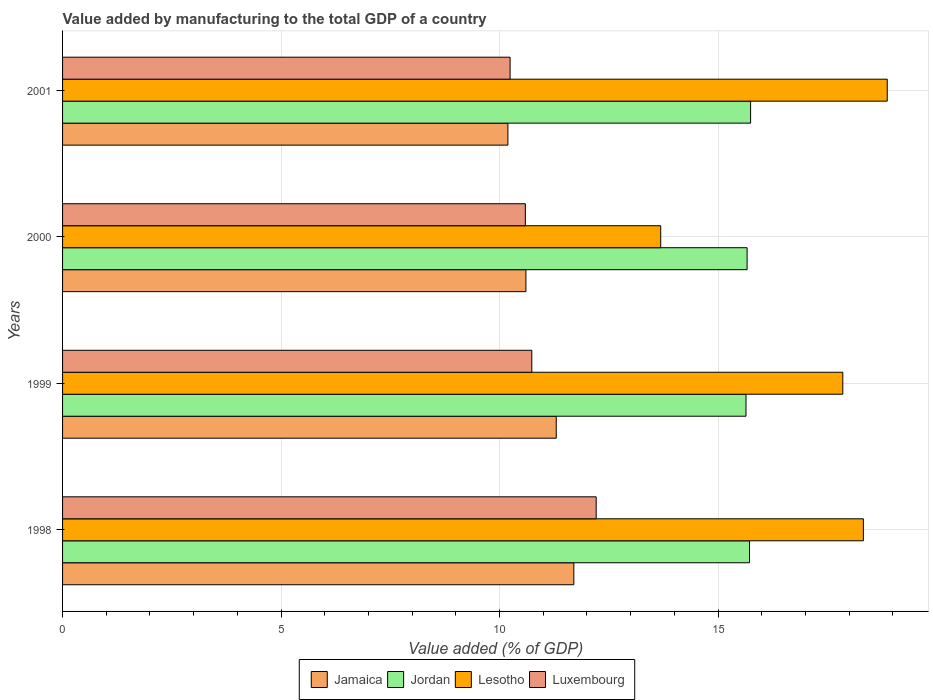How many bars are there on the 3rd tick from the bottom?
Ensure brevity in your answer.  4. In how many cases, is the number of bars for a given year not equal to the number of legend labels?
Offer a very short reply. 0. What is the value added by manufacturing to the total GDP in Lesotho in 1999?
Ensure brevity in your answer.  17.85. Across all years, what is the maximum value added by manufacturing to the total GDP in Lesotho?
Your answer should be compact. 18.87. Across all years, what is the minimum value added by manufacturing to the total GDP in Jordan?
Give a very brief answer. 15.64. In which year was the value added by manufacturing to the total GDP in Jordan minimum?
Your answer should be very brief. 1999. What is the total value added by manufacturing to the total GDP in Luxembourg in the graph?
Ensure brevity in your answer.  43.78. What is the difference between the value added by manufacturing to the total GDP in Jamaica in 1998 and that in 2000?
Provide a short and direct response. 1.1. What is the difference between the value added by manufacturing to the total GDP in Jamaica in 2000 and the value added by manufacturing to the total GDP in Luxembourg in 1999?
Make the answer very short. -0.13. What is the average value added by manufacturing to the total GDP in Luxembourg per year?
Make the answer very short. 10.94. In the year 1998, what is the difference between the value added by manufacturing to the total GDP in Lesotho and value added by manufacturing to the total GDP in Jamaica?
Make the answer very short. 6.63. What is the ratio of the value added by manufacturing to the total GDP in Jordan in 1999 to that in 2001?
Provide a succinct answer. 0.99. Is the value added by manufacturing to the total GDP in Jamaica in 1998 less than that in 1999?
Ensure brevity in your answer.  No. Is the difference between the value added by manufacturing to the total GDP in Lesotho in 1998 and 1999 greater than the difference between the value added by manufacturing to the total GDP in Jamaica in 1998 and 1999?
Provide a short and direct response. Yes. What is the difference between the highest and the second highest value added by manufacturing to the total GDP in Luxembourg?
Provide a succinct answer. 1.47. What is the difference between the highest and the lowest value added by manufacturing to the total GDP in Jamaica?
Ensure brevity in your answer.  1.51. Is the sum of the value added by manufacturing to the total GDP in Jamaica in 1998 and 2000 greater than the maximum value added by manufacturing to the total GDP in Lesotho across all years?
Your answer should be very brief. Yes. What does the 4th bar from the top in 2001 represents?
Provide a short and direct response. Jamaica. What does the 3rd bar from the bottom in 1999 represents?
Give a very brief answer. Lesotho. Is it the case that in every year, the sum of the value added by manufacturing to the total GDP in Lesotho and value added by manufacturing to the total GDP in Luxembourg is greater than the value added by manufacturing to the total GDP in Jamaica?
Provide a succinct answer. Yes. Are all the bars in the graph horizontal?
Keep it short and to the point. Yes. How many years are there in the graph?
Offer a very short reply. 4. Are the values on the major ticks of X-axis written in scientific E-notation?
Give a very brief answer. No. Does the graph contain any zero values?
Your answer should be very brief. No. Does the graph contain grids?
Ensure brevity in your answer.  Yes. How many legend labels are there?
Provide a succinct answer. 4. How are the legend labels stacked?
Your response must be concise. Horizontal. What is the title of the graph?
Keep it short and to the point. Value added by manufacturing to the total GDP of a country. Does "West Bank and Gaza" appear as one of the legend labels in the graph?
Provide a succinct answer. No. What is the label or title of the X-axis?
Give a very brief answer. Value added (% of GDP). What is the Value added (% of GDP) of Jamaica in 1998?
Provide a succinct answer. 11.7. What is the Value added (% of GDP) of Jordan in 1998?
Provide a succinct answer. 15.72. What is the Value added (% of GDP) in Lesotho in 1998?
Give a very brief answer. 18.32. What is the Value added (% of GDP) in Luxembourg in 1998?
Give a very brief answer. 12.21. What is the Value added (% of GDP) in Jamaica in 1999?
Your answer should be very brief. 11.3. What is the Value added (% of GDP) in Jordan in 1999?
Keep it short and to the point. 15.64. What is the Value added (% of GDP) in Lesotho in 1999?
Your answer should be compact. 17.85. What is the Value added (% of GDP) in Luxembourg in 1999?
Provide a succinct answer. 10.74. What is the Value added (% of GDP) in Jamaica in 2000?
Keep it short and to the point. 10.6. What is the Value added (% of GDP) of Jordan in 2000?
Ensure brevity in your answer.  15.66. What is the Value added (% of GDP) of Lesotho in 2000?
Make the answer very short. 13.69. What is the Value added (% of GDP) of Luxembourg in 2000?
Provide a succinct answer. 10.59. What is the Value added (% of GDP) in Jamaica in 2001?
Offer a very short reply. 10.19. What is the Value added (% of GDP) of Jordan in 2001?
Offer a very short reply. 15.74. What is the Value added (% of GDP) of Lesotho in 2001?
Provide a succinct answer. 18.87. What is the Value added (% of GDP) in Luxembourg in 2001?
Offer a very short reply. 10.24. Across all years, what is the maximum Value added (% of GDP) of Jamaica?
Your response must be concise. 11.7. Across all years, what is the maximum Value added (% of GDP) in Jordan?
Provide a short and direct response. 15.74. Across all years, what is the maximum Value added (% of GDP) in Lesotho?
Ensure brevity in your answer.  18.87. Across all years, what is the maximum Value added (% of GDP) in Luxembourg?
Your answer should be compact. 12.21. Across all years, what is the minimum Value added (% of GDP) in Jamaica?
Offer a very short reply. 10.19. Across all years, what is the minimum Value added (% of GDP) in Jordan?
Your answer should be compact. 15.64. Across all years, what is the minimum Value added (% of GDP) of Lesotho?
Give a very brief answer. 13.69. Across all years, what is the minimum Value added (% of GDP) in Luxembourg?
Your response must be concise. 10.24. What is the total Value added (% of GDP) of Jamaica in the graph?
Your answer should be compact. 43.79. What is the total Value added (% of GDP) of Jordan in the graph?
Offer a very short reply. 62.77. What is the total Value added (% of GDP) of Lesotho in the graph?
Provide a succinct answer. 68.74. What is the total Value added (% of GDP) in Luxembourg in the graph?
Ensure brevity in your answer.  43.78. What is the difference between the Value added (% of GDP) of Jamaica in 1998 and that in 1999?
Offer a terse response. 0.4. What is the difference between the Value added (% of GDP) of Jordan in 1998 and that in 1999?
Make the answer very short. 0.08. What is the difference between the Value added (% of GDP) in Lesotho in 1998 and that in 1999?
Give a very brief answer. 0.47. What is the difference between the Value added (% of GDP) of Luxembourg in 1998 and that in 1999?
Make the answer very short. 1.47. What is the difference between the Value added (% of GDP) in Jamaica in 1998 and that in 2000?
Ensure brevity in your answer.  1.1. What is the difference between the Value added (% of GDP) in Jordan in 1998 and that in 2000?
Your answer should be compact. 0.06. What is the difference between the Value added (% of GDP) in Lesotho in 1998 and that in 2000?
Ensure brevity in your answer.  4.64. What is the difference between the Value added (% of GDP) of Luxembourg in 1998 and that in 2000?
Your response must be concise. 1.62. What is the difference between the Value added (% of GDP) of Jamaica in 1998 and that in 2001?
Provide a short and direct response. 1.51. What is the difference between the Value added (% of GDP) of Jordan in 1998 and that in 2001?
Ensure brevity in your answer.  -0.02. What is the difference between the Value added (% of GDP) of Lesotho in 1998 and that in 2001?
Your response must be concise. -0.55. What is the difference between the Value added (% of GDP) in Luxembourg in 1998 and that in 2001?
Your answer should be compact. 1.97. What is the difference between the Value added (% of GDP) in Jamaica in 1999 and that in 2000?
Keep it short and to the point. 0.69. What is the difference between the Value added (% of GDP) in Jordan in 1999 and that in 2000?
Keep it short and to the point. -0.03. What is the difference between the Value added (% of GDP) of Lesotho in 1999 and that in 2000?
Offer a terse response. 4.17. What is the difference between the Value added (% of GDP) in Luxembourg in 1999 and that in 2000?
Your answer should be very brief. 0.15. What is the difference between the Value added (% of GDP) in Jamaica in 1999 and that in 2001?
Your answer should be very brief. 1.11. What is the difference between the Value added (% of GDP) in Jordan in 1999 and that in 2001?
Ensure brevity in your answer.  -0.11. What is the difference between the Value added (% of GDP) of Lesotho in 1999 and that in 2001?
Offer a terse response. -1.02. What is the difference between the Value added (% of GDP) of Luxembourg in 1999 and that in 2001?
Make the answer very short. 0.5. What is the difference between the Value added (% of GDP) in Jamaica in 2000 and that in 2001?
Make the answer very short. 0.41. What is the difference between the Value added (% of GDP) in Jordan in 2000 and that in 2001?
Ensure brevity in your answer.  -0.08. What is the difference between the Value added (% of GDP) in Lesotho in 2000 and that in 2001?
Offer a very short reply. -5.18. What is the difference between the Value added (% of GDP) of Luxembourg in 2000 and that in 2001?
Offer a terse response. 0.35. What is the difference between the Value added (% of GDP) of Jamaica in 1998 and the Value added (% of GDP) of Jordan in 1999?
Give a very brief answer. -3.94. What is the difference between the Value added (% of GDP) in Jamaica in 1998 and the Value added (% of GDP) in Lesotho in 1999?
Provide a short and direct response. -6.15. What is the difference between the Value added (% of GDP) in Jamaica in 1998 and the Value added (% of GDP) in Luxembourg in 1999?
Make the answer very short. 0.96. What is the difference between the Value added (% of GDP) in Jordan in 1998 and the Value added (% of GDP) in Lesotho in 1999?
Ensure brevity in your answer.  -2.13. What is the difference between the Value added (% of GDP) of Jordan in 1998 and the Value added (% of GDP) of Luxembourg in 1999?
Your response must be concise. 4.98. What is the difference between the Value added (% of GDP) of Lesotho in 1998 and the Value added (% of GDP) of Luxembourg in 1999?
Make the answer very short. 7.59. What is the difference between the Value added (% of GDP) of Jamaica in 1998 and the Value added (% of GDP) of Jordan in 2000?
Offer a very short reply. -3.96. What is the difference between the Value added (% of GDP) of Jamaica in 1998 and the Value added (% of GDP) of Lesotho in 2000?
Offer a very short reply. -1.99. What is the difference between the Value added (% of GDP) of Jamaica in 1998 and the Value added (% of GDP) of Luxembourg in 2000?
Provide a short and direct response. 1.11. What is the difference between the Value added (% of GDP) in Jordan in 1998 and the Value added (% of GDP) in Lesotho in 2000?
Offer a terse response. 2.03. What is the difference between the Value added (% of GDP) of Jordan in 1998 and the Value added (% of GDP) of Luxembourg in 2000?
Make the answer very short. 5.13. What is the difference between the Value added (% of GDP) of Lesotho in 1998 and the Value added (% of GDP) of Luxembourg in 2000?
Your answer should be compact. 7.73. What is the difference between the Value added (% of GDP) of Jamaica in 1998 and the Value added (% of GDP) of Jordan in 2001?
Give a very brief answer. -4.04. What is the difference between the Value added (% of GDP) of Jamaica in 1998 and the Value added (% of GDP) of Lesotho in 2001?
Your response must be concise. -7.17. What is the difference between the Value added (% of GDP) of Jamaica in 1998 and the Value added (% of GDP) of Luxembourg in 2001?
Your answer should be very brief. 1.46. What is the difference between the Value added (% of GDP) in Jordan in 1998 and the Value added (% of GDP) in Lesotho in 2001?
Offer a very short reply. -3.15. What is the difference between the Value added (% of GDP) of Jordan in 1998 and the Value added (% of GDP) of Luxembourg in 2001?
Make the answer very short. 5.48. What is the difference between the Value added (% of GDP) in Lesotho in 1998 and the Value added (% of GDP) in Luxembourg in 2001?
Keep it short and to the point. 8.08. What is the difference between the Value added (% of GDP) in Jamaica in 1999 and the Value added (% of GDP) in Jordan in 2000?
Give a very brief answer. -4.37. What is the difference between the Value added (% of GDP) of Jamaica in 1999 and the Value added (% of GDP) of Lesotho in 2000?
Your response must be concise. -2.39. What is the difference between the Value added (% of GDP) of Jamaica in 1999 and the Value added (% of GDP) of Luxembourg in 2000?
Your response must be concise. 0.71. What is the difference between the Value added (% of GDP) of Jordan in 1999 and the Value added (% of GDP) of Lesotho in 2000?
Give a very brief answer. 1.95. What is the difference between the Value added (% of GDP) in Jordan in 1999 and the Value added (% of GDP) in Luxembourg in 2000?
Ensure brevity in your answer.  5.05. What is the difference between the Value added (% of GDP) in Lesotho in 1999 and the Value added (% of GDP) in Luxembourg in 2000?
Your response must be concise. 7.26. What is the difference between the Value added (% of GDP) in Jamaica in 1999 and the Value added (% of GDP) in Jordan in 2001?
Offer a very short reply. -4.45. What is the difference between the Value added (% of GDP) in Jamaica in 1999 and the Value added (% of GDP) in Lesotho in 2001?
Provide a succinct answer. -7.57. What is the difference between the Value added (% of GDP) in Jamaica in 1999 and the Value added (% of GDP) in Luxembourg in 2001?
Provide a succinct answer. 1.06. What is the difference between the Value added (% of GDP) in Jordan in 1999 and the Value added (% of GDP) in Lesotho in 2001?
Make the answer very short. -3.23. What is the difference between the Value added (% of GDP) of Jordan in 1999 and the Value added (% of GDP) of Luxembourg in 2001?
Ensure brevity in your answer.  5.4. What is the difference between the Value added (% of GDP) of Lesotho in 1999 and the Value added (% of GDP) of Luxembourg in 2001?
Ensure brevity in your answer.  7.61. What is the difference between the Value added (% of GDP) in Jamaica in 2000 and the Value added (% of GDP) in Jordan in 2001?
Offer a very short reply. -5.14. What is the difference between the Value added (% of GDP) in Jamaica in 2000 and the Value added (% of GDP) in Lesotho in 2001?
Ensure brevity in your answer.  -8.27. What is the difference between the Value added (% of GDP) of Jamaica in 2000 and the Value added (% of GDP) of Luxembourg in 2001?
Give a very brief answer. 0.36. What is the difference between the Value added (% of GDP) in Jordan in 2000 and the Value added (% of GDP) in Lesotho in 2001?
Your response must be concise. -3.21. What is the difference between the Value added (% of GDP) in Jordan in 2000 and the Value added (% of GDP) in Luxembourg in 2001?
Your answer should be compact. 5.42. What is the difference between the Value added (% of GDP) in Lesotho in 2000 and the Value added (% of GDP) in Luxembourg in 2001?
Keep it short and to the point. 3.45. What is the average Value added (% of GDP) of Jamaica per year?
Provide a succinct answer. 10.95. What is the average Value added (% of GDP) in Jordan per year?
Ensure brevity in your answer.  15.69. What is the average Value added (% of GDP) of Lesotho per year?
Ensure brevity in your answer.  17.18. What is the average Value added (% of GDP) of Luxembourg per year?
Your response must be concise. 10.94. In the year 1998, what is the difference between the Value added (% of GDP) in Jamaica and Value added (% of GDP) in Jordan?
Provide a short and direct response. -4.02. In the year 1998, what is the difference between the Value added (% of GDP) of Jamaica and Value added (% of GDP) of Lesotho?
Make the answer very short. -6.63. In the year 1998, what is the difference between the Value added (% of GDP) in Jamaica and Value added (% of GDP) in Luxembourg?
Your answer should be very brief. -0.51. In the year 1998, what is the difference between the Value added (% of GDP) in Jordan and Value added (% of GDP) in Lesotho?
Provide a short and direct response. -2.6. In the year 1998, what is the difference between the Value added (% of GDP) in Jordan and Value added (% of GDP) in Luxembourg?
Your answer should be compact. 3.51. In the year 1998, what is the difference between the Value added (% of GDP) of Lesotho and Value added (% of GDP) of Luxembourg?
Your answer should be compact. 6.11. In the year 1999, what is the difference between the Value added (% of GDP) in Jamaica and Value added (% of GDP) in Jordan?
Your answer should be compact. -4.34. In the year 1999, what is the difference between the Value added (% of GDP) of Jamaica and Value added (% of GDP) of Lesotho?
Your answer should be compact. -6.56. In the year 1999, what is the difference between the Value added (% of GDP) of Jamaica and Value added (% of GDP) of Luxembourg?
Ensure brevity in your answer.  0.56. In the year 1999, what is the difference between the Value added (% of GDP) in Jordan and Value added (% of GDP) in Lesotho?
Offer a very short reply. -2.21. In the year 1999, what is the difference between the Value added (% of GDP) of Jordan and Value added (% of GDP) of Luxembourg?
Provide a succinct answer. 4.9. In the year 1999, what is the difference between the Value added (% of GDP) of Lesotho and Value added (% of GDP) of Luxembourg?
Keep it short and to the point. 7.12. In the year 2000, what is the difference between the Value added (% of GDP) of Jamaica and Value added (% of GDP) of Jordan?
Your response must be concise. -5.06. In the year 2000, what is the difference between the Value added (% of GDP) of Jamaica and Value added (% of GDP) of Lesotho?
Your response must be concise. -3.08. In the year 2000, what is the difference between the Value added (% of GDP) in Jamaica and Value added (% of GDP) in Luxembourg?
Offer a terse response. 0.01. In the year 2000, what is the difference between the Value added (% of GDP) in Jordan and Value added (% of GDP) in Lesotho?
Make the answer very short. 1.98. In the year 2000, what is the difference between the Value added (% of GDP) of Jordan and Value added (% of GDP) of Luxembourg?
Ensure brevity in your answer.  5.07. In the year 2000, what is the difference between the Value added (% of GDP) of Lesotho and Value added (% of GDP) of Luxembourg?
Offer a very short reply. 3.1. In the year 2001, what is the difference between the Value added (% of GDP) of Jamaica and Value added (% of GDP) of Jordan?
Provide a short and direct response. -5.55. In the year 2001, what is the difference between the Value added (% of GDP) in Jamaica and Value added (% of GDP) in Lesotho?
Your response must be concise. -8.68. In the year 2001, what is the difference between the Value added (% of GDP) in Jamaica and Value added (% of GDP) in Luxembourg?
Provide a short and direct response. -0.05. In the year 2001, what is the difference between the Value added (% of GDP) in Jordan and Value added (% of GDP) in Lesotho?
Give a very brief answer. -3.13. In the year 2001, what is the difference between the Value added (% of GDP) in Jordan and Value added (% of GDP) in Luxembourg?
Your answer should be compact. 5.5. In the year 2001, what is the difference between the Value added (% of GDP) in Lesotho and Value added (% of GDP) in Luxembourg?
Provide a short and direct response. 8.63. What is the ratio of the Value added (% of GDP) of Jamaica in 1998 to that in 1999?
Provide a succinct answer. 1.04. What is the ratio of the Value added (% of GDP) in Jordan in 1998 to that in 1999?
Your answer should be very brief. 1.01. What is the ratio of the Value added (% of GDP) in Lesotho in 1998 to that in 1999?
Give a very brief answer. 1.03. What is the ratio of the Value added (% of GDP) of Luxembourg in 1998 to that in 1999?
Offer a terse response. 1.14. What is the ratio of the Value added (% of GDP) of Jamaica in 1998 to that in 2000?
Give a very brief answer. 1.1. What is the ratio of the Value added (% of GDP) in Lesotho in 1998 to that in 2000?
Provide a succinct answer. 1.34. What is the ratio of the Value added (% of GDP) in Luxembourg in 1998 to that in 2000?
Keep it short and to the point. 1.15. What is the ratio of the Value added (% of GDP) of Jamaica in 1998 to that in 2001?
Your response must be concise. 1.15. What is the ratio of the Value added (% of GDP) in Jordan in 1998 to that in 2001?
Your response must be concise. 1. What is the ratio of the Value added (% of GDP) in Luxembourg in 1998 to that in 2001?
Ensure brevity in your answer.  1.19. What is the ratio of the Value added (% of GDP) in Jamaica in 1999 to that in 2000?
Offer a terse response. 1.07. What is the ratio of the Value added (% of GDP) of Lesotho in 1999 to that in 2000?
Provide a short and direct response. 1.3. What is the ratio of the Value added (% of GDP) in Jamaica in 1999 to that in 2001?
Give a very brief answer. 1.11. What is the ratio of the Value added (% of GDP) in Jordan in 1999 to that in 2001?
Provide a succinct answer. 0.99. What is the ratio of the Value added (% of GDP) of Lesotho in 1999 to that in 2001?
Give a very brief answer. 0.95. What is the ratio of the Value added (% of GDP) in Luxembourg in 1999 to that in 2001?
Offer a very short reply. 1.05. What is the ratio of the Value added (% of GDP) of Jamaica in 2000 to that in 2001?
Offer a very short reply. 1.04. What is the ratio of the Value added (% of GDP) of Lesotho in 2000 to that in 2001?
Your response must be concise. 0.73. What is the ratio of the Value added (% of GDP) in Luxembourg in 2000 to that in 2001?
Provide a succinct answer. 1.03. What is the difference between the highest and the second highest Value added (% of GDP) of Jamaica?
Provide a short and direct response. 0.4. What is the difference between the highest and the second highest Value added (% of GDP) of Jordan?
Ensure brevity in your answer.  0.02. What is the difference between the highest and the second highest Value added (% of GDP) of Lesotho?
Keep it short and to the point. 0.55. What is the difference between the highest and the second highest Value added (% of GDP) in Luxembourg?
Ensure brevity in your answer.  1.47. What is the difference between the highest and the lowest Value added (% of GDP) in Jamaica?
Offer a terse response. 1.51. What is the difference between the highest and the lowest Value added (% of GDP) in Jordan?
Your answer should be compact. 0.11. What is the difference between the highest and the lowest Value added (% of GDP) of Lesotho?
Keep it short and to the point. 5.18. What is the difference between the highest and the lowest Value added (% of GDP) in Luxembourg?
Offer a terse response. 1.97. 